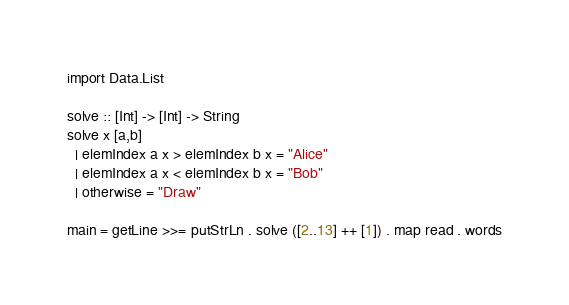<code> <loc_0><loc_0><loc_500><loc_500><_Haskell_>import Data.List

solve :: [Int] -> [Int] -> String
solve x [a,b]
  | elemIndex a x > elemIndex b x = "Alice"
  | elemIndex a x < elemIndex b x = "Bob"
  | otherwise = "Draw"

main = getLine >>= putStrLn . solve ([2..13] ++ [1]) . map read . words</code> 